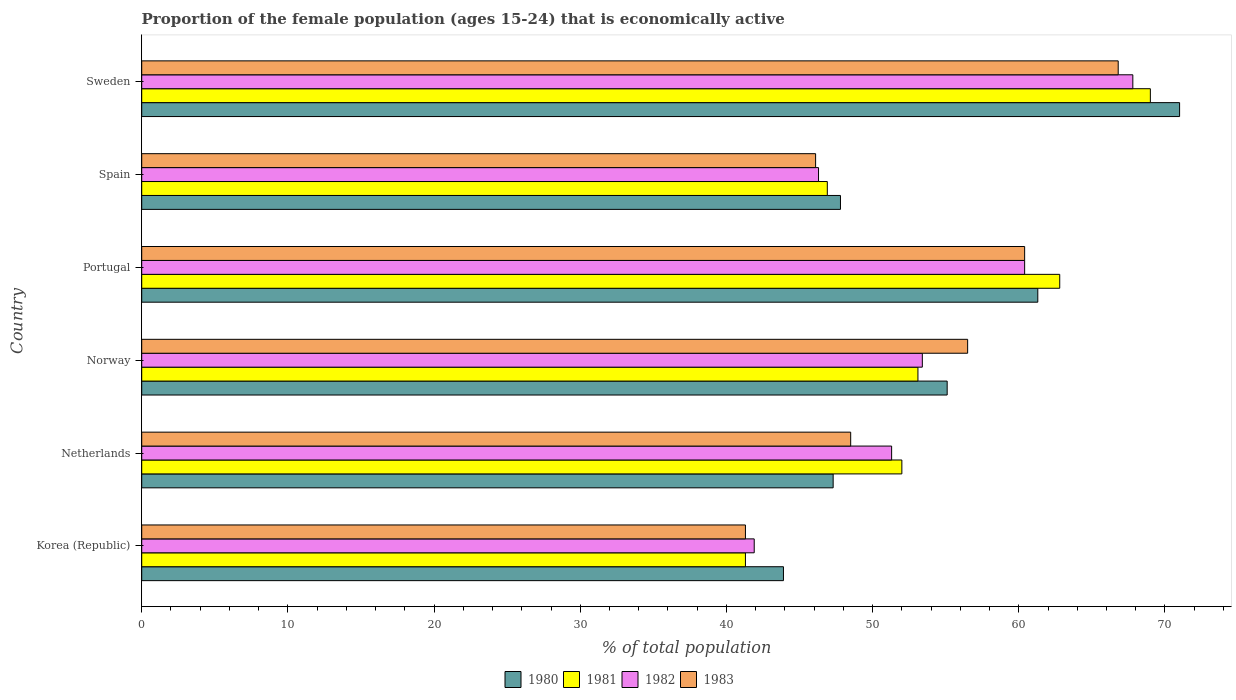How many different coloured bars are there?
Offer a very short reply. 4. How many groups of bars are there?
Your answer should be very brief. 6. Are the number of bars on each tick of the Y-axis equal?
Keep it short and to the point. Yes. How many bars are there on the 3rd tick from the top?
Offer a very short reply. 4. How many bars are there on the 2nd tick from the bottom?
Provide a short and direct response. 4. What is the label of the 6th group of bars from the top?
Your response must be concise. Korea (Republic). What is the proportion of the female population that is economically active in 1981 in Sweden?
Offer a very short reply. 69. Across all countries, what is the maximum proportion of the female population that is economically active in 1980?
Offer a terse response. 71. Across all countries, what is the minimum proportion of the female population that is economically active in 1981?
Provide a succinct answer. 41.3. In which country was the proportion of the female population that is economically active in 1982 maximum?
Make the answer very short. Sweden. What is the total proportion of the female population that is economically active in 1982 in the graph?
Your answer should be compact. 321.1. What is the difference between the proportion of the female population that is economically active in 1982 in Korea (Republic) and that in Portugal?
Your answer should be very brief. -18.5. What is the difference between the proportion of the female population that is economically active in 1983 in Portugal and the proportion of the female population that is economically active in 1981 in Norway?
Make the answer very short. 7.3. What is the average proportion of the female population that is economically active in 1983 per country?
Provide a short and direct response. 53.27. What is the difference between the proportion of the female population that is economically active in 1981 and proportion of the female population that is economically active in 1980 in Portugal?
Give a very brief answer. 1.5. In how many countries, is the proportion of the female population that is economically active in 1981 greater than 30 %?
Keep it short and to the point. 6. What is the ratio of the proportion of the female population that is economically active in 1981 in Portugal to that in Spain?
Give a very brief answer. 1.34. Is the proportion of the female population that is economically active in 1983 in Portugal less than that in Sweden?
Keep it short and to the point. Yes. What is the difference between the highest and the second highest proportion of the female population that is economically active in 1981?
Keep it short and to the point. 6.2. What is the difference between the highest and the lowest proportion of the female population that is economically active in 1980?
Provide a short and direct response. 27.1. In how many countries, is the proportion of the female population that is economically active in 1981 greater than the average proportion of the female population that is economically active in 1981 taken over all countries?
Your answer should be very brief. 2. Is the sum of the proportion of the female population that is economically active in 1983 in Norway and Sweden greater than the maximum proportion of the female population that is economically active in 1980 across all countries?
Your answer should be compact. Yes. Is it the case that in every country, the sum of the proportion of the female population that is economically active in 1981 and proportion of the female population that is economically active in 1982 is greater than the sum of proportion of the female population that is economically active in 1980 and proportion of the female population that is economically active in 1983?
Give a very brief answer. No. What does the 1st bar from the top in Norway represents?
Offer a terse response. 1983. What does the 2nd bar from the bottom in Norway represents?
Your answer should be compact. 1981. Is it the case that in every country, the sum of the proportion of the female population that is economically active in 1982 and proportion of the female population that is economically active in 1981 is greater than the proportion of the female population that is economically active in 1983?
Offer a terse response. Yes. How many bars are there?
Provide a short and direct response. 24. Are all the bars in the graph horizontal?
Offer a terse response. Yes. Are the values on the major ticks of X-axis written in scientific E-notation?
Offer a very short reply. No. Does the graph contain any zero values?
Your response must be concise. No. How many legend labels are there?
Your answer should be very brief. 4. What is the title of the graph?
Your response must be concise. Proportion of the female population (ages 15-24) that is economically active. What is the label or title of the X-axis?
Keep it short and to the point. % of total population. What is the % of total population of 1980 in Korea (Republic)?
Offer a terse response. 43.9. What is the % of total population of 1981 in Korea (Republic)?
Ensure brevity in your answer.  41.3. What is the % of total population of 1982 in Korea (Republic)?
Make the answer very short. 41.9. What is the % of total population of 1983 in Korea (Republic)?
Offer a terse response. 41.3. What is the % of total population in 1980 in Netherlands?
Offer a very short reply. 47.3. What is the % of total population of 1982 in Netherlands?
Make the answer very short. 51.3. What is the % of total population in 1983 in Netherlands?
Ensure brevity in your answer.  48.5. What is the % of total population in 1980 in Norway?
Your answer should be compact. 55.1. What is the % of total population of 1981 in Norway?
Offer a very short reply. 53.1. What is the % of total population in 1982 in Norway?
Give a very brief answer. 53.4. What is the % of total population of 1983 in Norway?
Your answer should be very brief. 56.5. What is the % of total population of 1980 in Portugal?
Ensure brevity in your answer.  61.3. What is the % of total population in 1981 in Portugal?
Your answer should be very brief. 62.8. What is the % of total population of 1982 in Portugal?
Your answer should be very brief. 60.4. What is the % of total population in 1983 in Portugal?
Give a very brief answer. 60.4. What is the % of total population of 1980 in Spain?
Give a very brief answer. 47.8. What is the % of total population of 1981 in Spain?
Your answer should be compact. 46.9. What is the % of total population of 1982 in Spain?
Offer a terse response. 46.3. What is the % of total population of 1983 in Spain?
Provide a succinct answer. 46.1. What is the % of total population in 1980 in Sweden?
Keep it short and to the point. 71. What is the % of total population in 1981 in Sweden?
Provide a succinct answer. 69. What is the % of total population of 1982 in Sweden?
Provide a short and direct response. 67.8. What is the % of total population of 1983 in Sweden?
Ensure brevity in your answer.  66.8. Across all countries, what is the maximum % of total population in 1981?
Your answer should be very brief. 69. Across all countries, what is the maximum % of total population in 1982?
Offer a very short reply. 67.8. Across all countries, what is the maximum % of total population in 1983?
Provide a succinct answer. 66.8. Across all countries, what is the minimum % of total population in 1980?
Ensure brevity in your answer.  43.9. Across all countries, what is the minimum % of total population in 1981?
Your response must be concise. 41.3. Across all countries, what is the minimum % of total population of 1982?
Offer a very short reply. 41.9. Across all countries, what is the minimum % of total population of 1983?
Make the answer very short. 41.3. What is the total % of total population in 1980 in the graph?
Offer a very short reply. 326.4. What is the total % of total population in 1981 in the graph?
Your answer should be compact. 325.1. What is the total % of total population of 1982 in the graph?
Your response must be concise. 321.1. What is the total % of total population of 1983 in the graph?
Make the answer very short. 319.6. What is the difference between the % of total population in 1983 in Korea (Republic) and that in Netherlands?
Provide a succinct answer. -7.2. What is the difference between the % of total population in 1980 in Korea (Republic) and that in Norway?
Provide a short and direct response. -11.2. What is the difference between the % of total population in 1982 in Korea (Republic) and that in Norway?
Offer a very short reply. -11.5. What is the difference between the % of total population in 1983 in Korea (Republic) and that in Norway?
Provide a short and direct response. -15.2. What is the difference between the % of total population in 1980 in Korea (Republic) and that in Portugal?
Give a very brief answer. -17.4. What is the difference between the % of total population of 1981 in Korea (Republic) and that in Portugal?
Your answer should be very brief. -21.5. What is the difference between the % of total population of 1982 in Korea (Republic) and that in Portugal?
Offer a terse response. -18.5. What is the difference between the % of total population of 1983 in Korea (Republic) and that in Portugal?
Your answer should be compact. -19.1. What is the difference between the % of total population in 1980 in Korea (Republic) and that in Spain?
Your answer should be compact. -3.9. What is the difference between the % of total population in 1982 in Korea (Republic) and that in Spain?
Make the answer very short. -4.4. What is the difference between the % of total population in 1980 in Korea (Republic) and that in Sweden?
Provide a succinct answer. -27.1. What is the difference between the % of total population in 1981 in Korea (Republic) and that in Sweden?
Make the answer very short. -27.7. What is the difference between the % of total population in 1982 in Korea (Republic) and that in Sweden?
Make the answer very short. -25.9. What is the difference between the % of total population of 1983 in Korea (Republic) and that in Sweden?
Your response must be concise. -25.5. What is the difference between the % of total population in 1982 in Netherlands and that in Norway?
Provide a succinct answer. -2.1. What is the difference between the % of total population of 1980 in Netherlands and that in Portugal?
Offer a terse response. -14. What is the difference between the % of total population in 1983 in Netherlands and that in Portugal?
Offer a very short reply. -11.9. What is the difference between the % of total population of 1981 in Netherlands and that in Spain?
Provide a short and direct response. 5.1. What is the difference between the % of total population in 1982 in Netherlands and that in Spain?
Your response must be concise. 5. What is the difference between the % of total population of 1983 in Netherlands and that in Spain?
Keep it short and to the point. 2.4. What is the difference between the % of total population of 1980 in Netherlands and that in Sweden?
Ensure brevity in your answer.  -23.7. What is the difference between the % of total population in 1981 in Netherlands and that in Sweden?
Offer a terse response. -17. What is the difference between the % of total population in 1982 in Netherlands and that in Sweden?
Make the answer very short. -16.5. What is the difference between the % of total population in 1983 in Netherlands and that in Sweden?
Your response must be concise. -18.3. What is the difference between the % of total population of 1980 in Norway and that in Portugal?
Your answer should be compact. -6.2. What is the difference between the % of total population of 1983 in Norway and that in Portugal?
Offer a terse response. -3.9. What is the difference between the % of total population in 1980 in Norway and that in Spain?
Provide a succinct answer. 7.3. What is the difference between the % of total population of 1983 in Norway and that in Spain?
Keep it short and to the point. 10.4. What is the difference between the % of total population of 1980 in Norway and that in Sweden?
Your answer should be compact. -15.9. What is the difference between the % of total population in 1981 in Norway and that in Sweden?
Offer a very short reply. -15.9. What is the difference between the % of total population of 1982 in Norway and that in Sweden?
Make the answer very short. -14.4. What is the difference between the % of total population in 1983 in Norway and that in Sweden?
Your response must be concise. -10.3. What is the difference between the % of total population of 1980 in Portugal and that in Spain?
Give a very brief answer. 13.5. What is the difference between the % of total population in 1981 in Portugal and that in Spain?
Provide a short and direct response. 15.9. What is the difference between the % of total population in 1980 in Portugal and that in Sweden?
Offer a terse response. -9.7. What is the difference between the % of total population of 1981 in Portugal and that in Sweden?
Your response must be concise. -6.2. What is the difference between the % of total population in 1980 in Spain and that in Sweden?
Your answer should be compact. -23.2. What is the difference between the % of total population of 1981 in Spain and that in Sweden?
Provide a short and direct response. -22.1. What is the difference between the % of total population in 1982 in Spain and that in Sweden?
Offer a terse response. -21.5. What is the difference between the % of total population of 1983 in Spain and that in Sweden?
Give a very brief answer. -20.7. What is the difference between the % of total population in 1980 in Korea (Republic) and the % of total population in 1981 in Netherlands?
Provide a short and direct response. -8.1. What is the difference between the % of total population of 1980 in Korea (Republic) and the % of total population of 1983 in Netherlands?
Offer a terse response. -4.6. What is the difference between the % of total population of 1981 in Korea (Republic) and the % of total population of 1982 in Netherlands?
Provide a succinct answer. -10. What is the difference between the % of total population in 1982 in Korea (Republic) and the % of total population in 1983 in Netherlands?
Offer a very short reply. -6.6. What is the difference between the % of total population of 1980 in Korea (Republic) and the % of total population of 1981 in Norway?
Offer a terse response. -9.2. What is the difference between the % of total population in 1980 in Korea (Republic) and the % of total population in 1983 in Norway?
Your answer should be very brief. -12.6. What is the difference between the % of total population of 1981 in Korea (Republic) and the % of total population of 1982 in Norway?
Your response must be concise. -12.1. What is the difference between the % of total population of 1981 in Korea (Republic) and the % of total population of 1983 in Norway?
Offer a terse response. -15.2. What is the difference between the % of total population of 1982 in Korea (Republic) and the % of total population of 1983 in Norway?
Your answer should be very brief. -14.6. What is the difference between the % of total population of 1980 in Korea (Republic) and the % of total population of 1981 in Portugal?
Make the answer very short. -18.9. What is the difference between the % of total population of 1980 in Korea (Republic) and the % of total population of 1982 in Portugal?
Your response must be concise. -16.5. What is the difference between the % of total population of 1980 in Korea (Republic) and the % of total population of 1983 in Portugal?
Your answer should be compact. -16.5. What is the difference between the % of total population of 1981 in Korea (Republic) and the % of total population of 1982 in Portugal?
Provide a short and direct response. -19.1. What is the difference between the % of total population of 1981 in Korea (Republic) and the % of total population of 1983 in Portugal?
Make the answer very short. -19.1. What is the difference between the % of total population of 1982 in Korea (Republic) and the % of total population of 1983 in Portugal?
Your response must be concise. -18.5. What is the difference between the % of total population of 1981 in Korea (Republic) and the % of total population of 1983 in Spain?
Your response must be concise. -4.8. What is the difference between the % of total population of 1982 in Korea (Republic) and the % of total population of 1983 in Spain?
Provide a succinct answer. -4.2. What is the difference between the % of total population of 1980 in Korea (Republic) and the % of total population of 1981 in Sweden?
Keep it short and to the point. -25.1. What is the difference between the % of total population in 1980 in Korea (Republic) and the % of total population in 1982 in Sweden?
Your response must be concise. -23.9. What is the difference between the % of total population of 1980 in Korea (Republic) and the % of total population of 1983 in Sweden?
Give a very brief answer. -22.9. What is the difference between the % of total population of 1981 in Korea (Republic) and the % of total population of 1982 in Sweden?
Provide a succinct answer. -26.5. What is the difference between the % of total population of 1981 in Korea (Republic) and the % of total population of 1983 in Sweden?
Ensure brevity in your answer.  -25.5. What is the difference between the % of total population of 1982 in Korea (Republic) and the % of total population of 1983 in Sweden?
Provide a short and direct response. -24.9. What is the difference between the % of total population of 1980 in Netherlands and the % of total population of 1983 in Norway?
Your answer should be very brief. -9.2. What is the difference between the % of total population of 1980 in Netherlands and the % of total population of 1981 in Portugal?
Your answer should be compact. -15.5. What is the difference between the % of total population in 1980 in Netherlands and the % of total population in 1982 in Portugal?
Your answer should be compact. -13.1. What is the difference between the % of total population in 1981 in Netherlands and the % of total population in 1982 in Portugal?
Offer a very short reply. -8.4. What is the difference between the % of total population of 1981 in Netherlands and the % of total population of 1983 in Portugal?
Keep it short and to the point. -8.4. What is the difference between the % of total population in 1980 in Netherlands and the % of total population in 1981 in Spain?
Make the answer very short. 0.4. What is the difference between the % of total population of 1980 in Netherlands and the % of total population of 1981 in Sweden?
Offer a terse response. -21.7. What is the difference between the % of total population of 1980 in Netherlands and the % of total population of 1982 in Sweden?
Ensure brevity in your answer.  -20.5. What is the difference between the % of total population of 1980 in Netherlands and the % of total population of 1983 in Sweden?
Keep it short and to the point. -19.5. What is the difference between the % of total population in 1981 in Netherlands and the % of total population in 1982 in Sweden?
Provide a short and direct response. -15.8. What is the difference between the % of total population in 1981 in Netherlands and the % of total population in 1983 in Sweden?
Keep it short and to the point. -14.8. What is the difference between the % of total population in 1982 in Netherlands and the % of total population in 1983 in Sweden?
Your answer should be compact. -15.5. What is the difference between the % of total population of 1980 in Norway and the % of total population of 1981 in Portugal?
Keep it short and to the point. -7.7. What is the difference between the % of total population of 1980 in Norway and the % of total population of 1983 in Portugal?
Make the answer very short. -5.3. What is the difference between the % of total population in 1981 in Norway and the % of total population in 1983 in Portugal?
Your response must be concise. -7.3. What is the difference between the % of total population of 1982 in Norway and the % of total population of 1983 in Portugal?
Offer a terse response. -7. What is the difference between the % of total population in 1980 in Norway and the % of total population in 1982 in Spain?
Ensure brevity in your answer.  8.8. What is the difference between the % of total population in 1981 in Norway and the % of total population in 1982 in Spain?
Offer a terse response. 6.8. What is the difference between the % of total population in 1980 in Norway and the % of total population in 1981 in Sweden?
Offer a terse response. -13.9. What is the difference between the % of total population in 1980 in Norway and the % of total population in 1982 in Sweden?
Ensure brevity in your answer.  -12.7. What is the difference between the % of total population of 1981 in Norway and the % of total population of 1982 in Sweden?
Keep it short and to the point. -14.7. What is the difference between the % of total population of 1981 in Norway and the % of total population of 1983 in Sweden?
Make the answer very short. -13.7. What is the difference between the % of total population in 1982 in Norway and the % of total population in 1983 in Sweden?
Offer a very short reply. -13.4. What is the difference between the % of total population in 1980 in Portugal and the % of total population in 1983 in Spain?
Ensure brevity in your answer.  15.2. What is the difference between the % of total population of 1981 in Portugal and the % of total population of 1982 in Spain?
Ensure brevity in your answer.  16.5. What is the difference between the % of total population in 1981 in Portugal and the % of total population in 1983 in Spain?
Your answer should be very brief. 16.7. What is the difference between the % of total population in 1982 in Portugal and the % of total population in 1983 in Spain?
Offer a terse response. 14.3. What is the difference between the % of total population of 1980 in Portugal and the % of total population of 1981 in Sweden?
Your answer should be very brief. -7.7. What is the difference between the % of total population in 1980 in Portugal and the % of total population in 1982 in Sweden?
Offer a very short reply. -6.5. What is the difference between the % of total population in 1981 in Portugal and the % of total population in 1982 in Sweden?
Offer a very short reply. -5. What is the difference between the % of total population of 1982 in Portugal and the % of total population of 1983 in Sweden?
Your answer should be very brief. -6.4. What is the difference between the % of total population of 1980 in Spain and the % of total population of 1981 in Sweden?
Ensure brevity in your answer.  -21.2. What is the difference between the % of total population of 1980 in Spain and the % of total population of 1982 in Sweden?
Your response must be concise. -20. What is the difference between the % of total population of 1981 in Spain and the % of total population of 1982 in Sweden?
Make the answer very short. -20.9. What is the difference between the % of total population in 1981 in Spain and the % of total population in 1983 in Sweden?
Make the answer very short. -19.9. What is the difference between the % of total population of 1982 in Spain and the % of total population of 1983 in Sweden?
Ensure brevity in your answer.  -20.5. What is the average % of total population of 1980 per country?
Offer a very short reply. 54.4. What is the average % of total population in 1981 per country?
Your response must be concise. 54.18. What is the average % of total population in 1982 per country?
Provide a succinct answer. 53.52. What is the average % of total population of 1983 per country?
Give a very brief answer. 53.27. What is the difference between the % of total population in 1980 and % of total population in 1981 in Korea (Republic)?
Give a very brief answer. 2.6. What is the difference between the % of total population in 1981 and % of total population in 1982 in Korea (Republic)?
Ensure brevity in your answer.  -0.6. What is the difference between the % of total population in 1982 and % of total population in 1983 in Korea (Republic)?
Provide a short and direct response. 0.6. What is the difference between the % of total population of 1980 and % of total population of 1981 in Netherlands?
Ensure brevity in your answer.  -4.7. What is the difference between the % of total population in 1980 and % of total population in 1983 in Netherlands?
Your answer should be compact. -1.2. What is the difference between the % of total population of 1981 and % of total population of 1983 in Netherlands?
Ensure brevity in your answer.  3.5. What is the difference between the % of total population in 1982 and % of total population in 1983 in Netherlands?
Keep it short and to the point. 2.8. What is the difference between the % of total population in 1980 and % of total population in 1983 in Norway?
Your response must be concise. -1.4. What is the difference between the % of total population of 1981 and % of total population of 1982 in Norway?
Provide a succinct answer. -0.3. What is the difference between the % of total population of 1981 and % of total population of 1983 in Norway?
Make the answer very short. -3.4. What is the difference between the % of total population of 1982 and % of total population of 1983 in Norway?
Your response must be concise. -3.1. What is the difference between the % of total population of 1980 and % of total population of 1981 in Portugal?
Provide a short and direct response. -1.5. What is the difference between the % of total population in 1980 and % of total population in 1982 in Portugal?
Offer a very short reply. 0.9. What is the difference between the % of total population of 1981 and % of total population of 1982 in Portugal?
Your answer should be compact. 2.4. What is the difference between the % of total population in 1980 and % of total population in 1981 in Spain?
Give a very brief answer. 0.9. What is the difference between the % of total population in 1981 and % of total population in 1982 in Spain?
Offer a terse response. 0.6. What is the difference between the % of total population of 1981 and % of total population of 1983 in Spain?
Make the answer very short. 0.8. What is the difference between the % of total population of 1980 and % of total population of 1981 in Sweden?
Your response must be concise. 2. What is the difference between the % of total population in 1980 and % of total population in 1982 in Sweden?
Give a very brief answer. 3.2. What is the difference between the % of total population of 1981 and % of total population of 1983 in Sweden?
Give a very brief answer. 2.2. What is the difference between the % of total population of 1982 and % of total population of 1983 in Sweden?
Your answer should be compact. 1. What is the ratio of the % of total population of 1980 in Korea (Republic) to that in Netherlands?
Offer a terse response. 0.93. What is the ratio of the % of total population of 1981 in Korea (Republic) to that in Netherlands?
Make the answer very short. 0.79. What is the ratio of the % of total population in 1982 in Korea (Republic) to that in Netherlands?
Ensure brevity in your answer.  0.82. What is the ratio of the % of total population in 1983 in Korea (Republic) to that in Netherlands?
Ensure brevity in your answer.  0.85. What is the ratio of the % of total population in 1980 in Korea (Republic) to that in Norway?
Provide a succinct answer. 0.8. What is the ratio of the % of total population in 1982 in Korea (Republic) to that in Norway?
Offer a very short reply. 0.78. What is the ratio of the % of total population of 1983 in Korea (Republic) to that in Norway?
Keep it short and to the point. 0.73. What is the ratio of the % of total population in 1980 in Korea (Republic) to that in Portugal?
Offer a very short reply. 0.72. What is the ratio of the % of total population in 1981 in Korea (Republic) to that in Portugal?
Offer a terse response. 0.66. What is the ratio of the % of total population of 1982 in Korea (Republic) to that in Portugal?
Your response must be concise. 0.69. What is the ratio of the % of total population in 1983 in Korea (Republic) to that in Portugal?
Your response must be concise. 0.68. What is the ratio of the % of total population in 1980 in Korea (Republic) to that in Spain?
Your response must be concise. 0.92. What is the ratio of the % of total population of 1981 in Korea (Republic) to that in Spain?
Give a very brief answer. 0.88. What is the ratio of the % of total population in 1982 in Korea (Republic) to that in Spain?
Provide a short and direct response. 0.91. What is the ratio of the % of total population of 1983 in Korea (Republic) to that in Spain?
Make the answer very short. 0.9. What is the ratio of the % of total population in 1980 in Korea (Republic) to that in Sweden?
Offer a very short reply. 0.62. What is the ratio of the % of total population in 1981 in Korea (Republic) to that in Sweden?
Keep it short and to the point. 0.6. What is the ratio of the % of total population of 1982 in Korea (Republic) to that in Sweden?
Your answer should be compact. 0.62. What is the ratio of the % of total population in 1983 in Korea (Republic) to that in Sweden?
Keep it short and to the point. 0.62. What is the ratio of the % of total population of 1980 in Netherlands to that in Norway?
Ensure brevity in your answer.  0.86. What is the ratio of the % of total population of 1981 in Netherlands to that in Norway?
Your answer should be compact. 0.98. What is the ratio of the % of total population in 1982 in Netherlands to that in Norway?
Your answer should be compact. 0.96. What is the ratio of the % of total population in 1983 in Netherlands to that in Norway?
Provide a succinct answer. 0.86. What is the ratio of the % of total population in 1980 in Netherlands to that in Portugal?
Your answer should be very brief. 0.77. What is the ratio of the % of total population in 1981 in Netherlands to that in Portugal?
Keep it short and to the point. 0.83. What is the ratio of the % of total population in 1982 in Netherlands to that in Portugal?
Provide a succinct answer. 0.85. What is the ratio of the % of total population in 1983 in Netherlands to that in Portugal?
Offer a terse response. 0.8. What is the ratio of the % of total population of 1980 in Netherlands to that in Spain?
Your answer should be very brief. 0.99. What is the ratio of the % of total population in 1981 in Netherlands to that in Spain?
Your answer should be compact. 1.11. What is the ratio of the % of total population in 1982 in Netherlands to that in Spain?
Keep it short and to the point. 1.11. What is the ratio of the % of total population in 1983 in Netherlands to that in Spain?
Keep it short and to the point. 1.05. What is the ratio of the % of total population in 1980 in Netherlands to that in Sweden?
Make the answer very short. 0.67. What is the ratio of the % of total population in 1981 in Netherlands to that in Sweden?
Offer a terse response. 0.75. What is the ratio of the % of total population in 1982 in Netherlands to that in Sweden?
Keep it short and to the point. 0.76. What is the ratio of the % of total population in 1983 in Netherlands to that in Sweden?
Make the answer very short. 0.73. What is the ratio of the % of total population of 1980 in Norway to that in Portugal?
Offer a terse response. 0.9. What is the ratio of the % of total population in 1981 in Norway to that in Portugal?
Provide a succinct answer. 0.85. What is the ratio of the % of total population in 1982 in Norway to that in Portugal?
Ensure brevity in your answer.  0.88. What is the ratio of the % of total population in 1983 in Norway to that in Portugal?
Provide a short and direct response. 0.94. What is the ratio of the % of total population in 1980 in Norway to that in Spain?
Offer a very short reply. 1.15. What is the ratio of the % of total population in 1981 in Norway to that in Spain?
Offer a very short reply. 1.13. What is the ratio of the % of total population of 1982 in Norway to that in Spain?
Keep it short and to the point. 1.15. What is the ratio of the % of total population in 1983 in Norway to that in Spain?
Keep it short and to the point. 1.23. What is the ratio of the % of total population in 1980 in Norway to that in Sweden?
Provide a short and direct response. 0.78. What is the ratio of the % of total population of 1981 in Norway to that in Sweden?
Provide a short and direct response. 0.77. What is the ratio of the % of total population in 1982 in Norway to that in Sweden?
Provide a succinct answer. 0.79. What is the ratio of the % of total population in 1983 in Norway to that in Sweden?
Offer a terse response. 0.85. What is the ratio of the % of total population of 1980 in Portugal to that in Spain?
Offer a very short reply. 1.28. What is the ratio of the % of total population of 1981 in Portugal to that in Spain?
Offer a very short reply. 1.34. What is the ratio of the % of total population in 1982 in Portugal to that in Spain?
Make the answer very short. 1.3. What is the ratio of the % of total population in 1983 in Portugal to that in Spain?
Provide a succinct answer. 1.31. What is the ratio of the % of total population in 1980 in Portugal to that in Sweden?
Offer a terse response. 0.86. What is the ratio of the % of total population in 1981 in Portugal to that in Sweden?
Offer a very short reply. 0.91. What is the ratio of the % of total population in 1982 in Portugal to that in Sweden?
Your answer should be very brief. 0.89. What is the ratio of the % of total population in 1983 in Portugal to that in Sweden?
Your response must be concise. 0.9. What is the ratio of the % of total population in 1980 in Spain to that in Sweden?
Keep it short and to the point. 0.67. What is the ratio of the % of total population in 1981 in Spain to that in Sweden?
Provide a succinct answer. 0.68. What is the ratio of the % of total population in 1982 in Spain to that in Sweden?
Give a very brief answer. 0.68. What is the ratio of the % of total population of 1983 in Spain to that in Sweden?
Your response must be concise. 0.69. What is the difference between the highest and the second highest % of total population of 1980?
Your response must be concise. 9.7. What is the difference between the highest and the second highest % of total population in 1981?
Keep it short and to the point. 6.2. What is the difference between the highest and the second highest % of total population of 1983?
Your answer should be very brief. 6.4. What is the difference between the highest and the lowest % of total population in 1980?
Keep it short and to the point. 27.1. What is the difference between the highest and the lowest % of total population of 1981?
Provide a succinct answer. 27.7. What is the difference between the highest and the lowest % of total population in 1982?
Keep it short and to the point. 25.9. What is the difference between the highest and the lowest % of total population of 1983?
Make the answer very short. 25.5. 